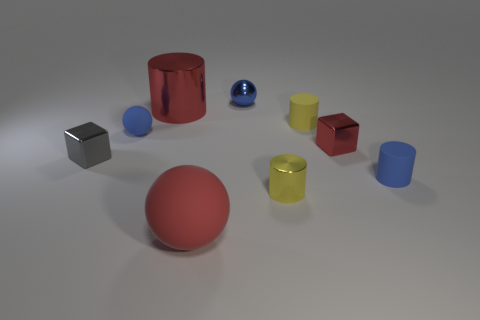Are there fewer small yellow cylinders that are right of the big red metallic cylinder than yellow things that are behind the yellow matte cylinder?
Your response must be concise. No. What number of other objects are there of the same size as the blue shiny ball?
Ensure brevity in your answer.  6. Is the large red ball made of the same material as the block to the left of the tiny blue rubber sphere?
Offer a terse response. No. How many things are either blue things behind the tiny blue cylinder or tiny cylinders behind the tiny yellow metallic cylinder?
Offer a terse response. 4. The large rubber object has what color?
Keep it short and to the point. Red. Are there fewer tiny red blocks that are in front of the big red metal object than blue objects?
Give a very brief answer. Yes. Is there any other thing that is the same shape as the small gray thing?
Offer a terse response. Yes. Is there a big green shiny ball?
Provide a succinct answer. No. Are there fewer tiny blue spheres than tiny red metal objects?
Ensure brevity in your answer.  No. How many small gray cubes have the same material as the small blue cylinder?
Your response must be concise. 0. 